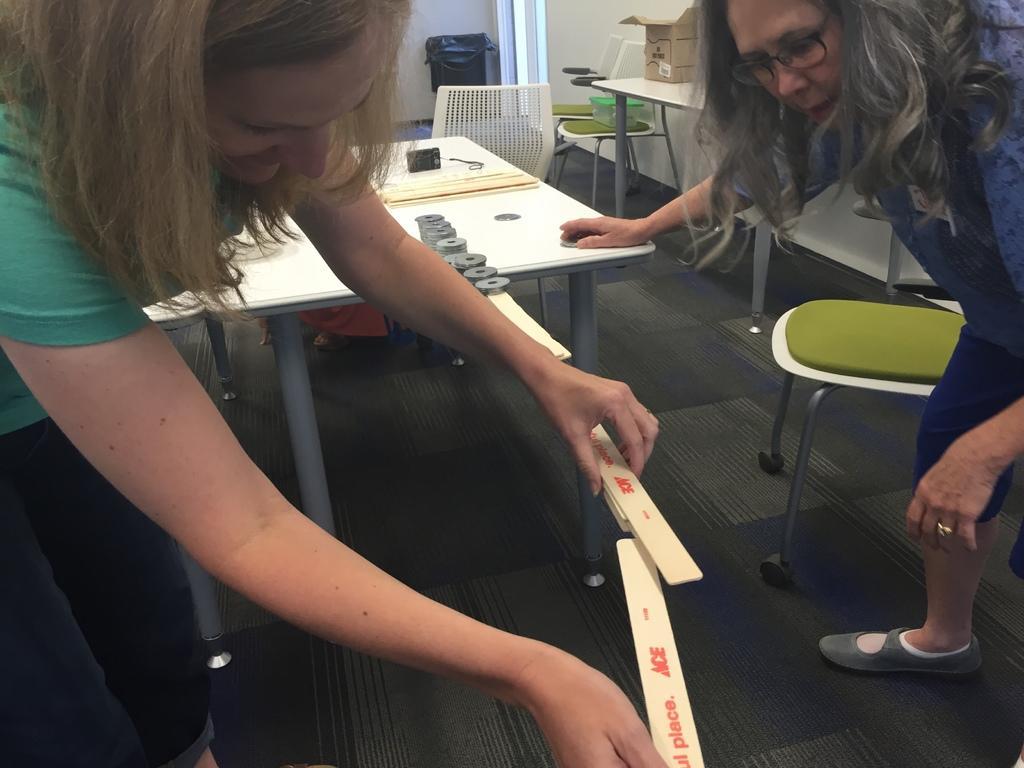In one or two sentences, can you explain what this image depicts? In this picture we can see a trash can. Chairs and a box on it. We can see a camera on the table. We can see two women holding sticks in hands and making some experiment. This is a floor. We can see a cardboard box on a table. 